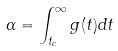Convert formula to latex. <formula><loc_0><loc_0><loc_500><loc_500>\alpha = \int _ { t _ { c } } ^ { \infty } g ( t ) d t</formula> 